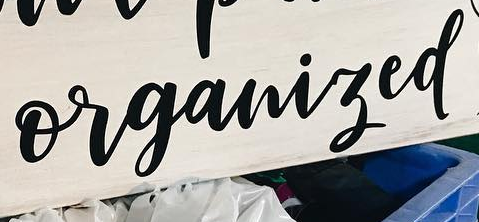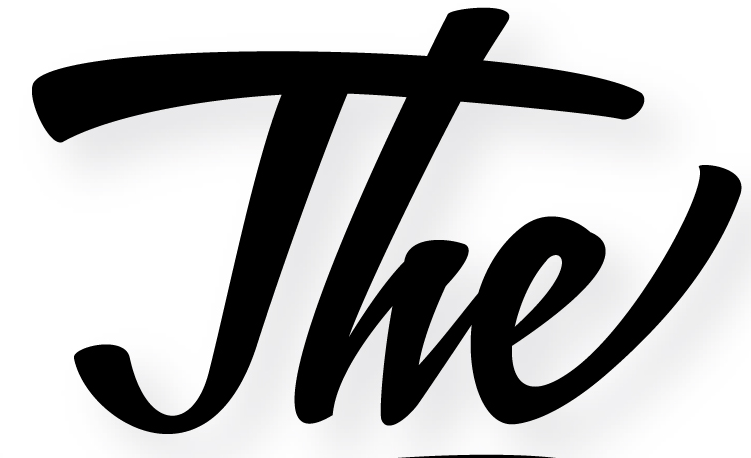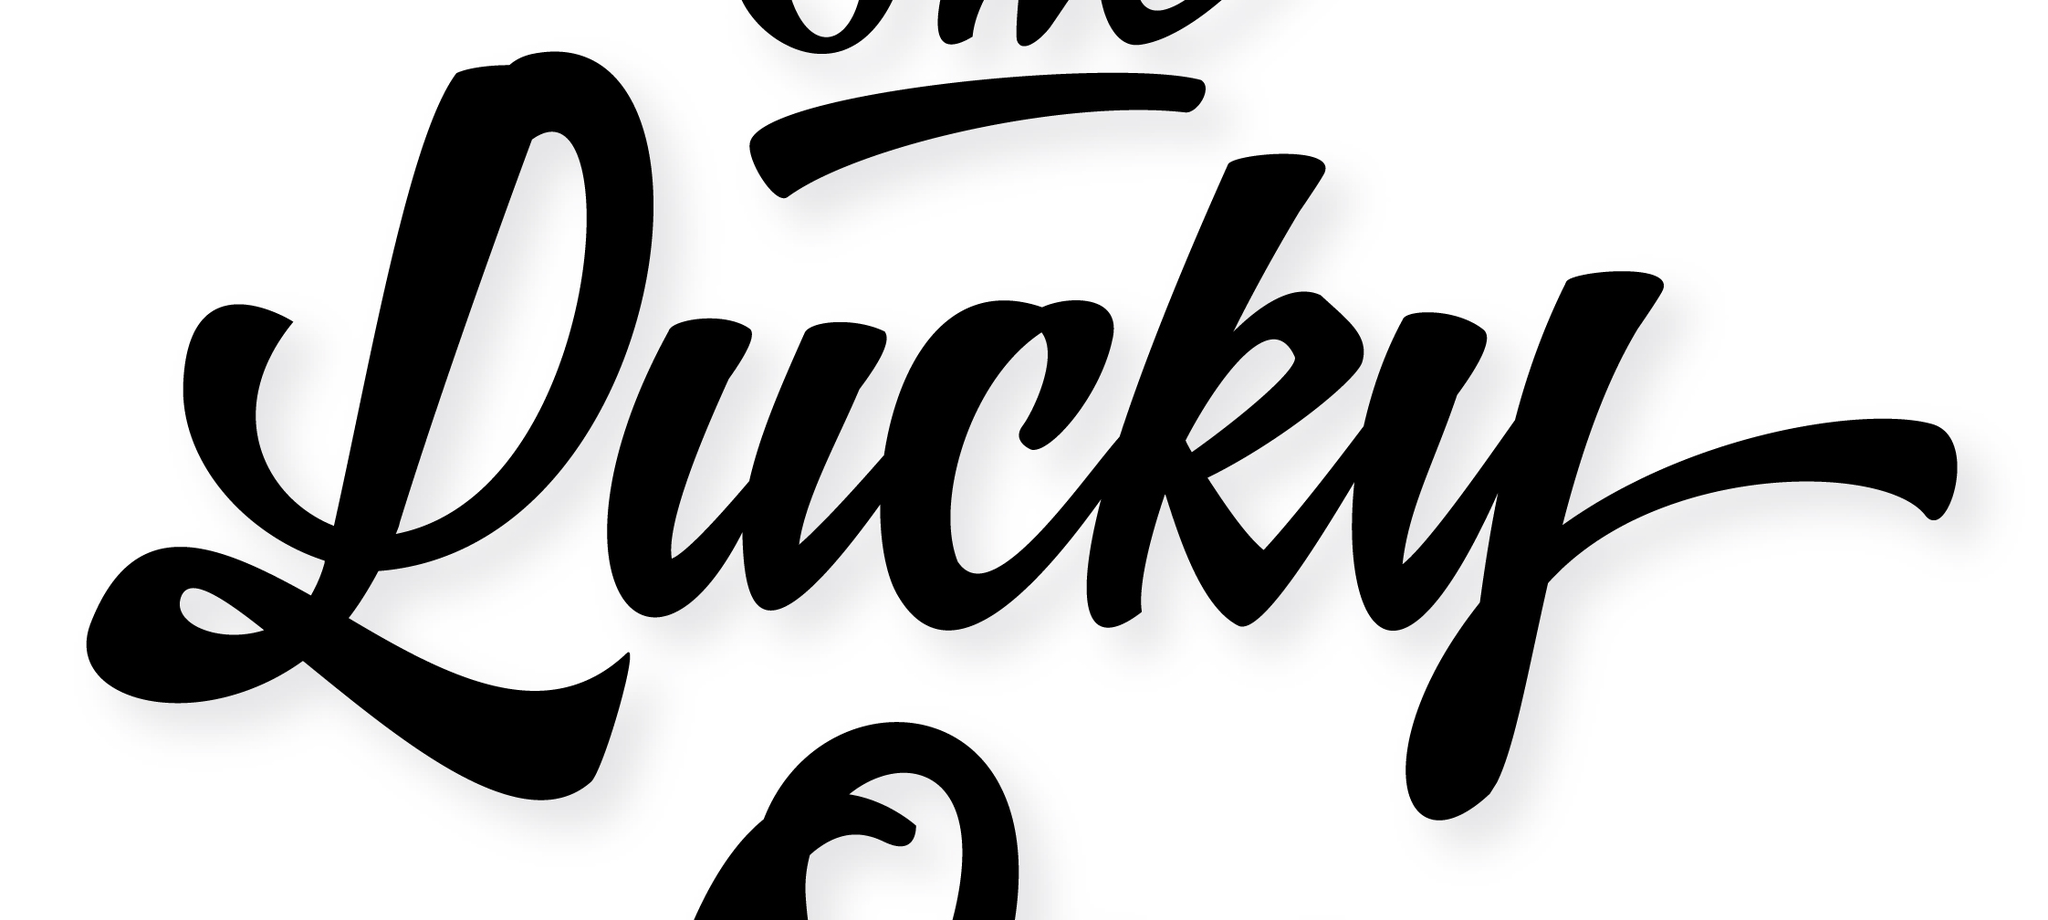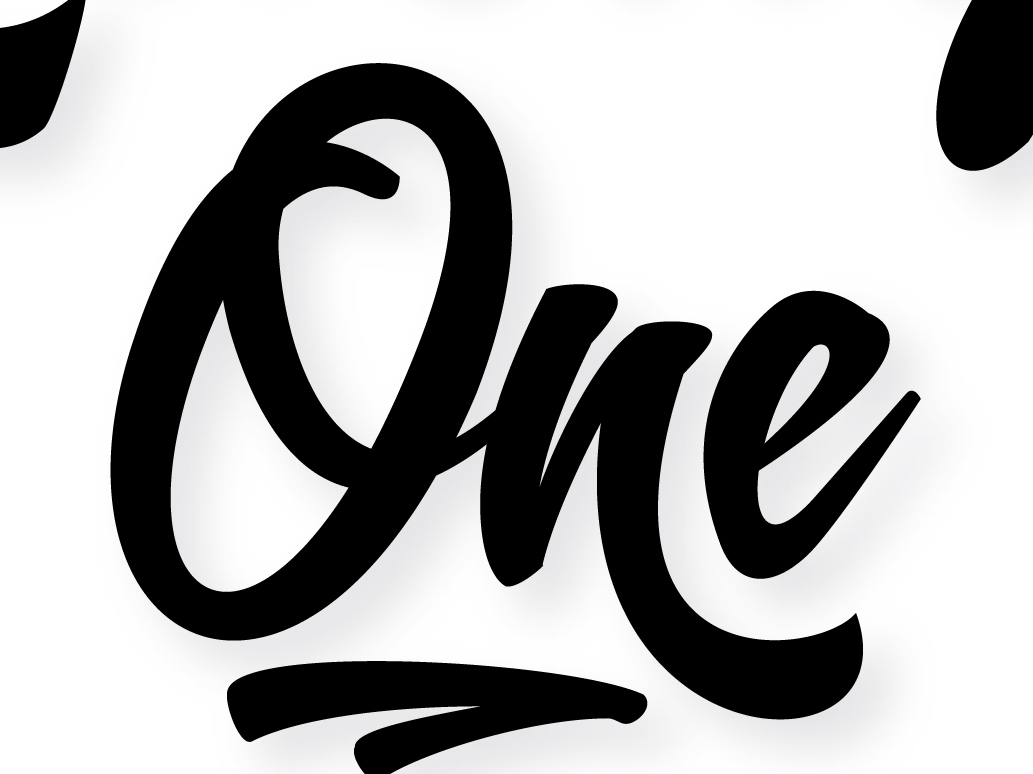Read the text content from these images in order, separated by a semicolon. organized; The; Lucky; One 